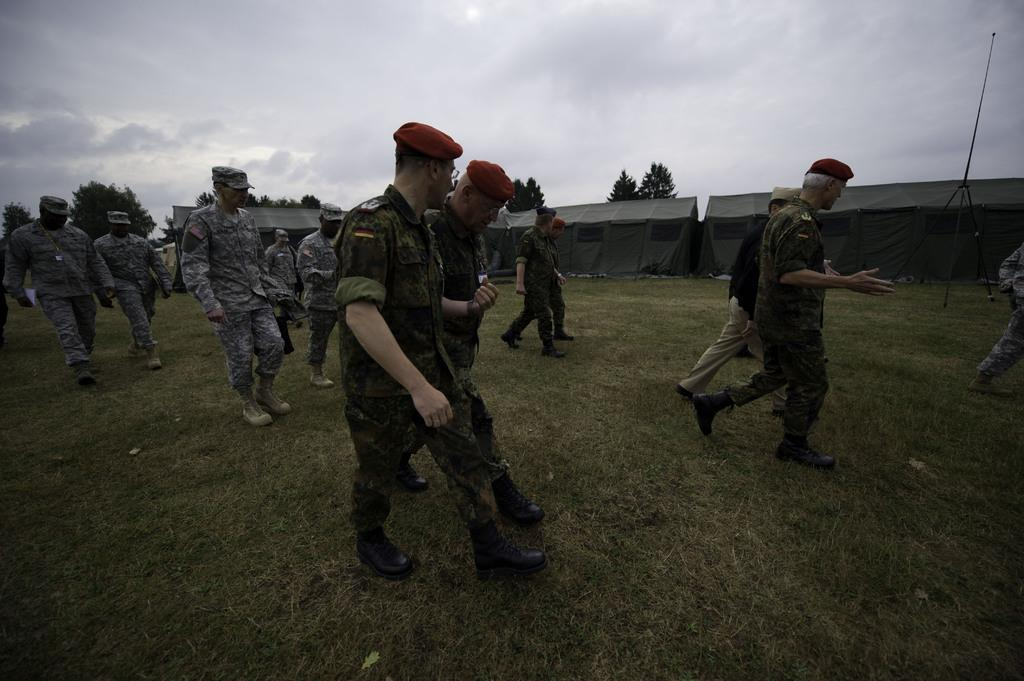What are the men in the image doing? The men in the image are walking on the ground. What can be seen in the image besides the men? There are grey-colored tents in the image. What is visible in the background of the image? There are trees and a cloudy sky in the background of the image. What type of pets are kept in the drawer in the image? There is no drawer or pets present in the image. 